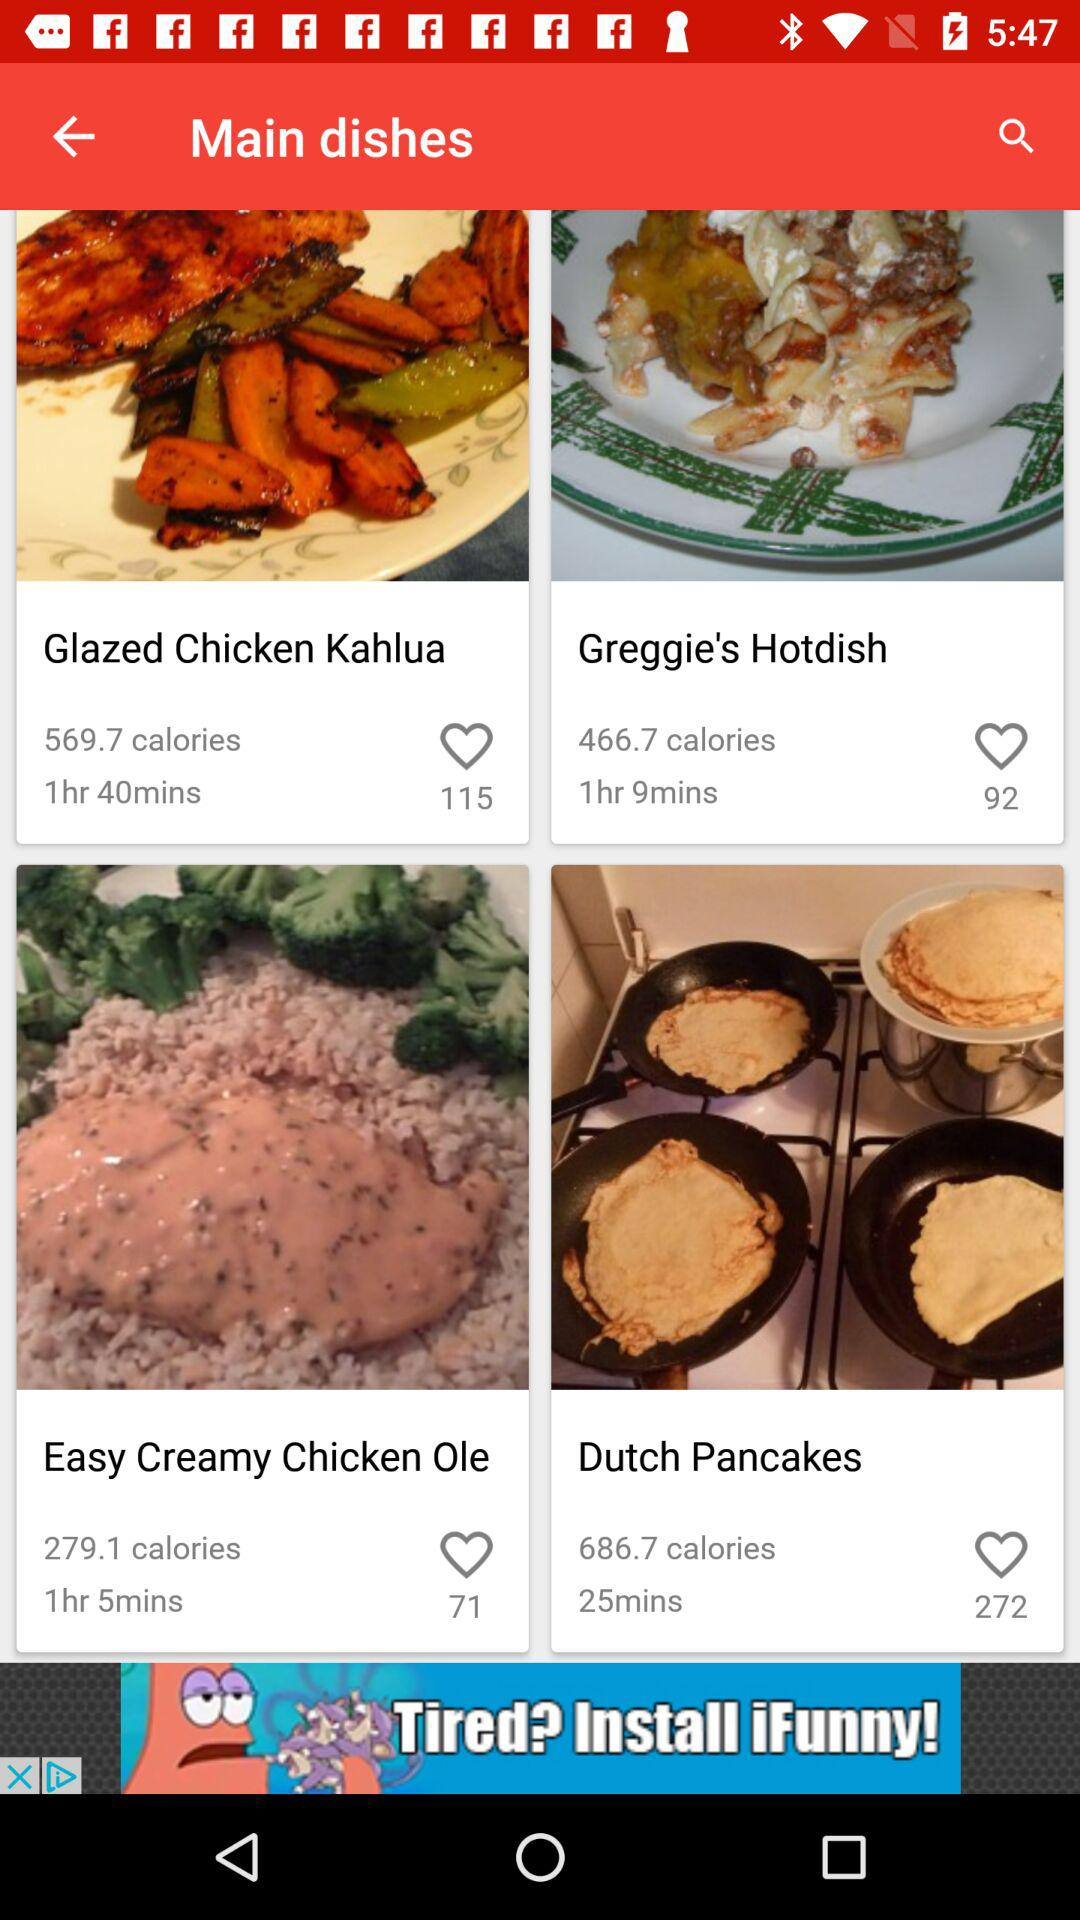What is the number of likes for "Greggie's Hotdish"? The number of likes for "Greggie's Hotdish" is 92. 